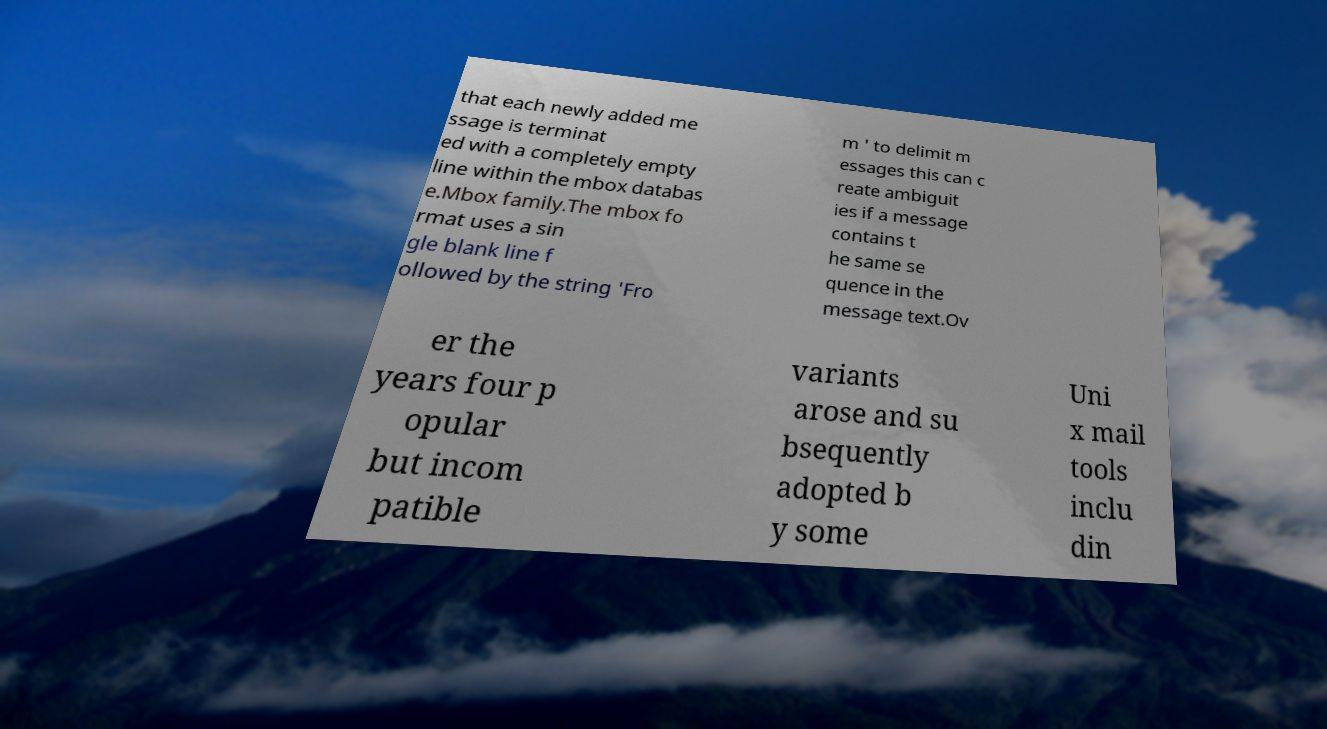What messages or text are displayed in this image? I need them in a readable, typed format. that each newly added me ssage is terminat ed with a completely empty line within the mbox databas e.Mbox family.The mbox fo rmat uses a sin gle blank line f ollowed by the string 'Fro m ' to delimit m essages this can c reate ambiguit ies if a message contains t he same se quence in the message text.Ov er the years four p opular but incom patible variants arose and su bsequently adopted b y some Uni x mail tools inclu din 